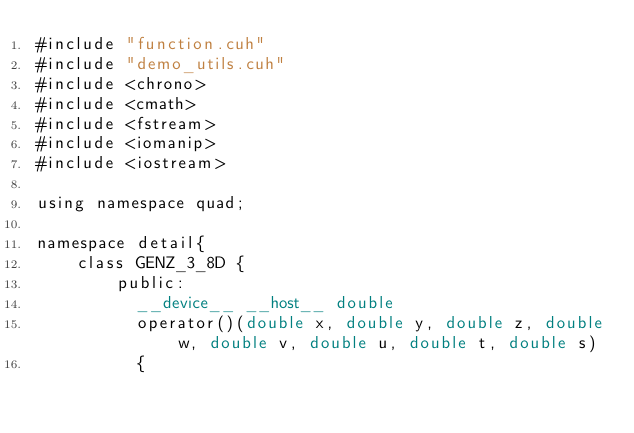<code> <loc_0><loc_0><loc_500><loc_500><_Cuda_>#include "function.cuh"
#include "demo_utils.cuh"
#include <chrono>
#include <cmath>
#include <fstream>
#include <iomanip>
#include <iostream>

using namespace quad;

namespace detail{
    class GENZ_3_8D {
        public:
          __device__ __host__ double
          operator()(double x, double y, double z, double w, double v, double u, double t, double s)
          {</code> 